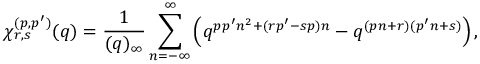Convert formula to latex. <formula><loc_0><loc_0><loc_500><loc_500>\chi _ { r , s } ^ { ( p , p ^ { \prime } ) } ( q ) = \frac { 1 } { ( q ) _ { \infty } } \sum _ { n = - \infty } ^ { \infty } \left ( q ^ { p p ^ { \prime } n ^ { 2 } + ( r p ^ { \prime } - s p ) n } - q ^ { ( p n + r ) ( p ^ { \prime } n + s ) } \right ) ,</formula> 